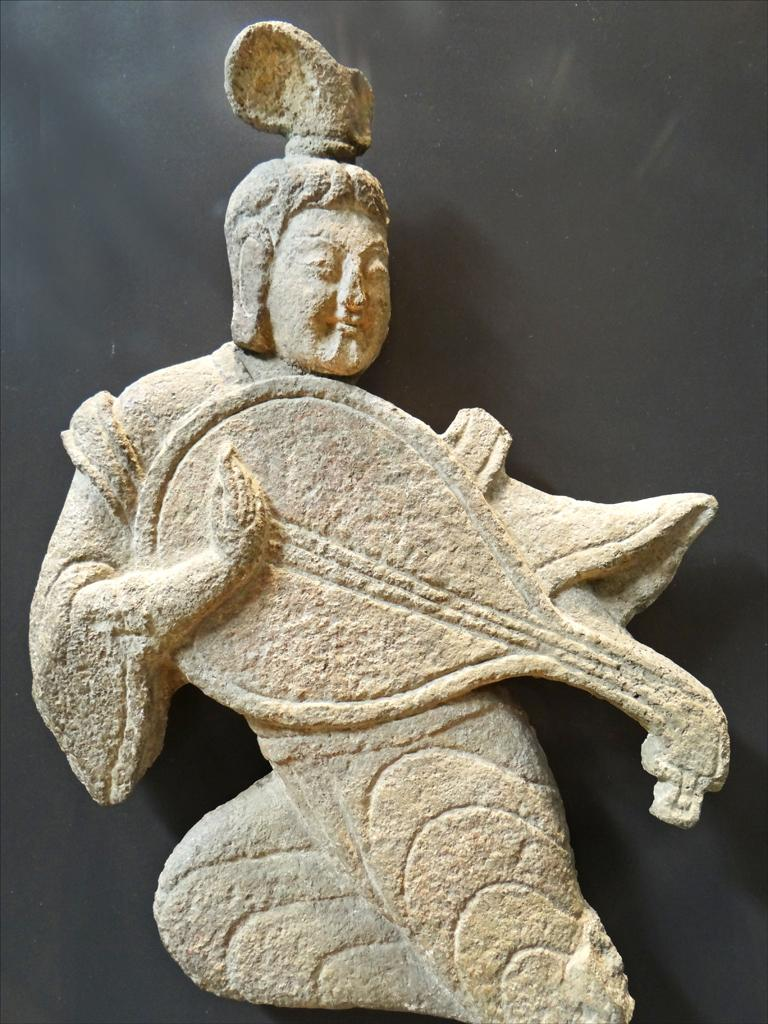What is the main subject in the image? There is a statue in the image. What material is the statue made of? The statue is made by carving stone. Where is the throne located in the image? There is no throne present in the image. What type of milk is being poured over the statue in the image? There is no milk present in the image. What part of the body is the statue using to lick the stone in the image? There is no tongue or licking action present in the image. 